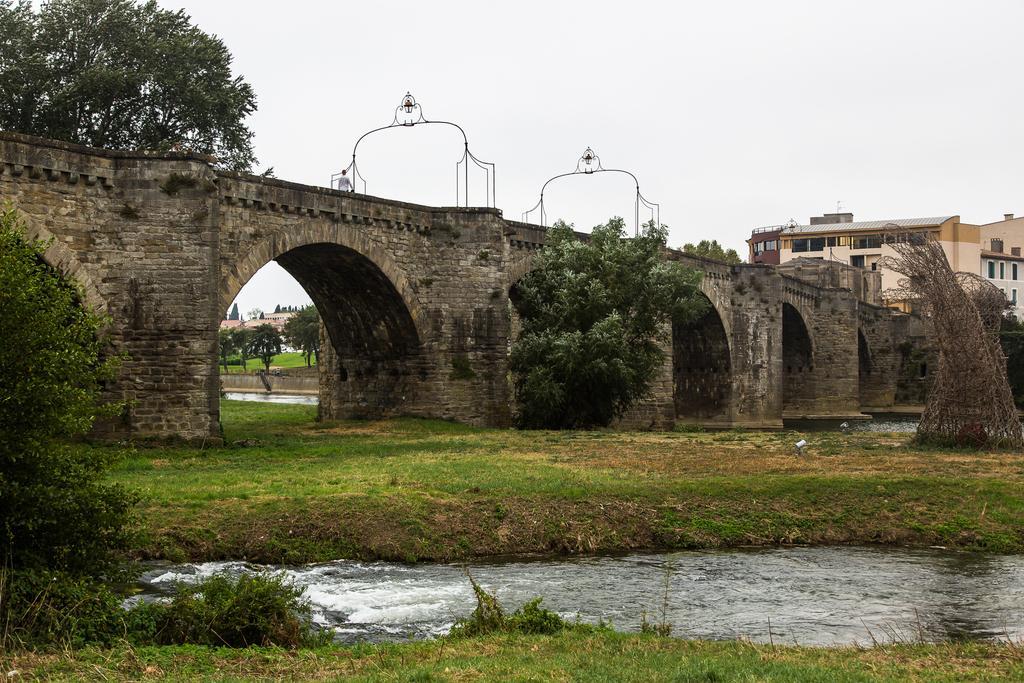Describe this image in one or two sentences. In the center of the image there is a bridge and tree. On the bridge there are lights. At the bottom we can see water and grass. On the right side there is a building. On the left we can see trees. In the background there are buildings, trees, sky. 